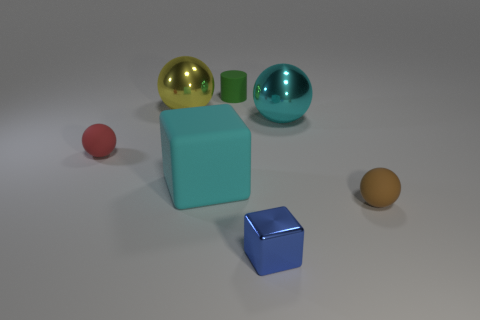Add 2 brown metallic spheres. How many objects exist? 9 Subtract all cylinders. How many objects are left? 6 Subtract all big brown shiny spheres. Subtract all big cyan spheres. How many objects are left? 6 Add 1 small blue objects. How many small blue objects are left? 2 Add 7 red matte things. How many red matte things exist? 8 Subtract 1 cyan spheres. How many objects are left? 6 